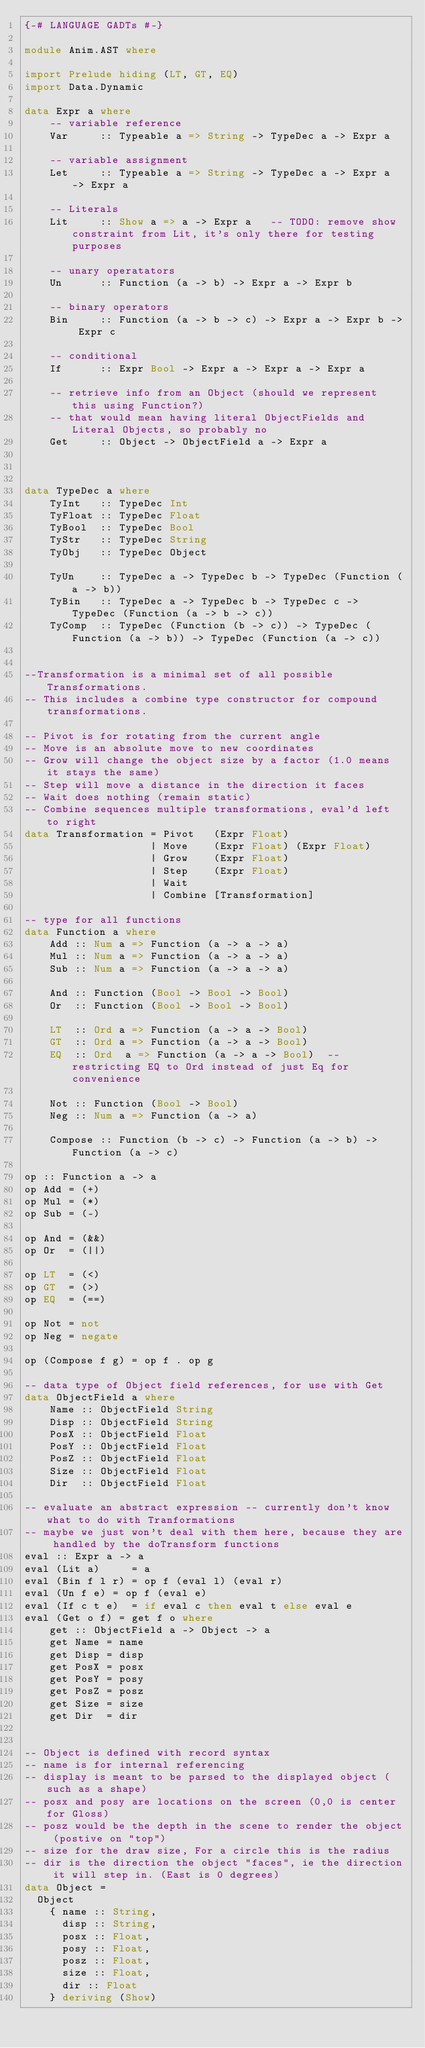Convert code to text. <code><loc_0><loc_0><loc_500><loc_500><_Haskell_>{-# LANGUAGE GADTs #-}

module Anim.AST where

import Prelude hiding (LT, GT, EQ)
import Data.Dynamic

data Expr a where
    -- variable reference
    Var     :: Typeable a => String -> TypeDec a -> Expr a

    -- variable assignment
    Let     :: Typeable a => String -> TypeDec a -> Expr a -> Expr a

    -- Literals
    Lit     :: Show a => a -> Expr a   -- TODO: remove show constraint from Lit, it's only there for testing purposes

    -- unary operatators
    Un      :: Function (a -> b) -> Expr a -> Expr b

    -- binary operators
    Bin     :: Function (a -> b -> c) -> Expr a -> Expr b -> Expr c

    -- conditional
    If      :: Expr Bool -> Expr a -> Expr a -> Expr a

    -- retrieve info from an Object (should we represent this using Function?)
    -- that would mean having literal ObjectFields and Literal Objects, so probably no
    Get     :: Object -> ObjectField a -> Expr a



data TypeDec a where
    TyInt   :: TypeDec Int
    TyFloat :: TypeDec Float
    TyBool  :: TypeDec Bool
    TyStr   :: TypeDec String
    TyObj   :: TypeDec Object

    TyUn    :: TypeDec a -> TypeDec b -> TypeDec (Function (a -> b))
    TyBin   :: TypeDec a -> TypeDec b -> TypeDec c -> TypeDec (Function (a -> b -> c))
    TyComp  :: TypeDec (Function (b -> c)) -> TypeDec (Function (a -> b)) -> TypeDec (Function (a -> c))


--Transformation is a minimal set of all possible Transformations.
-- This includes a combine type constructor for compound transformations.

-- Pivot is for rotating from the current angle
-- Move is an absolute move to new coordinates
-- Grow will change the object size by a factor (1.0 means it stays the same)
-- Step will move a distance in the direction it faces
-- Wait does nothing (remain static)
-- Combine sequences multiple transformations, eval'd left to right
data Transformation = Pivot   (Expr Float)
                    | Move    (Expr Float) (Expr Float)
                    | Grow    (Expr Float)
                    | Step    (Expr Float)
                    | Wait
                    | Combine [Transformation]

-- type for all functions
data Function a where
    Add :: Num a => Function (a -> a -> a)
    Mul :: Num a => Function (a -> a -> a)
    Sub :: Num a => Function (a -> a -> a)

    And :: Function (Bool -> Bool -> Bool)
    Or  :: Function (Bool -> Bool -> Bool)

    LT  :: Ord a => Function (a -> a -> Bool)
    GT  :: Ord a => Function (a -> a -> Bool)
    EQ  :: Ord  a => Function (a -> a -> Bool)  -- restricting EQ to Ord instead of just Eq for convenience

    Not :: Function (Bool -> Bool)
    Neg :: Num a => Function (a -> a)

    Compose :: Function (b -> c) -> Function (a -> b) -> Function (a -> c)

op :: Function a -> a
op Add = (+)
op Mul = (*)
op Sub = (-)

op And = (&&)
op Or  = (||)

op LT  = (<)
op GT  = (>)
op EQ  = (==)

op Not = not
op Neg = negate

op (Compose f g) = op f . op g

-- data type of Object field references, for use with Get
data ObjectField a where
    Name :: ObjectField String
    Disp :: ObjectField String
    PosX :: ObjectField Float
    PosY :: ObjectField Float
    PosZ :: ObjectField Float
    Size :: ObjectField Float
    Dir  :: ObjectField Float

-- evaluate an abstract expression -- currently don't know what to do with Tranformations
-- maybe we just won't deal with them here, because they are handled by the doTransform functions
eval :: Expr a -> a
eval (Lit a)     = a
eval (Bin f l r) = op f (eval l) (eval r)
eval (Un f e) = op f (eval e)
eval (If c t e)  = if eval c then eval t else eval e
eval (Get o f) = get f o where
    get :: ObjectField a -> Object -> a
    get Name = name
    get Disp = disp
    get PosX = posx
    get PosY = posy
    get PosZ = posz
    get Size = size
    get Dir  = dir


-- Object is defined with record syntax
-- name is for internal referencing
-- display is meant to be parsed to the displayed object (such as a shape)
-- posx and posy are locations on the screen (0,0 is center for Gloss)
-- posz would be the depth in the scene to render the object (postive on "top")
-- size for the draw size, For a circle this is the radius
-- dir is the direction the object "faces", ie the direction it will step in. (East is 0 degrees)
data Object =
  Object
    { name :: String,
      disp :: String,
      posx :: Float,
      posy :: Float,
      posz :: Float,
      size :: Float,
      dir :: Float
    } deriving (Show)
</code> 